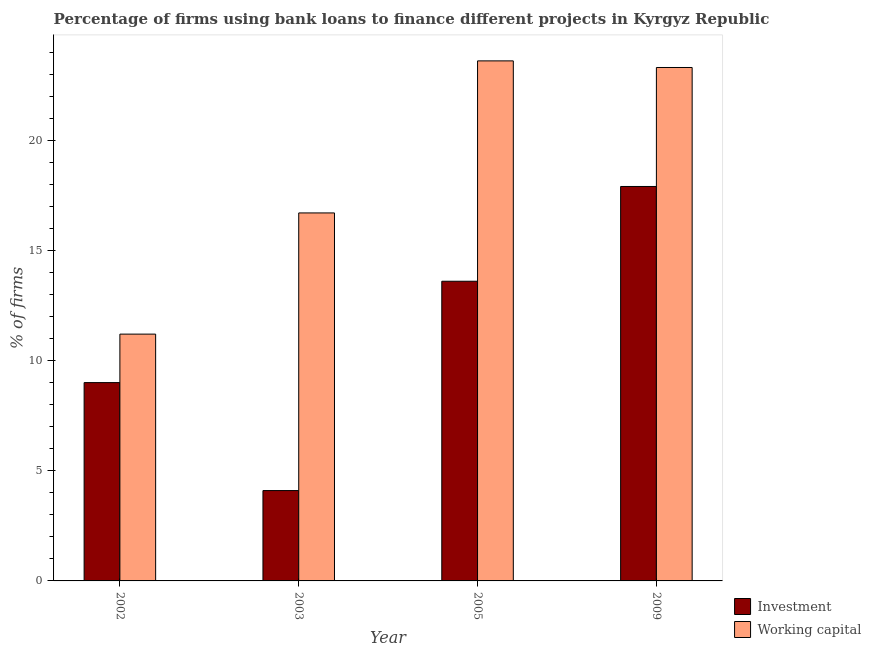How many different coloured bars are there?
Offer a terse response. 2. Are the number of bars on each tick of the X-axis equal?
Give a very brief answer. Yes. What is the label of the 3rd group of bars from the left?
Keep it short and to the point. 2005. What is the percentage of firms using banks to finance working capital in 2003?
Your response must be concise. 16.7. Across all years, what is the maximum percentage of firms using banks to finance investment?
Provide a succinct answer. 17.9. In which year was the percentage of firms using banks to finance investment minimum?
Offer a very short reply. 2003. What is the total percentage of firms using banks to finance investment in the graph?
Offer a very short reply. 44.6. What is the difference between the percentage of firms using banks to finance working capital in 2005 and that in 2009?
Your response must be concise. 0.3. What is the difference between the percentage of firms using banks to finance working capital in 2002 and the percentage of firms using banks to finance investment in 2003?
Ensure brevity in your answer.  -5.5. What is the average percentage of firms using banks to finance investment per year?
Your answer should be very brief. 11.15. In the year 2005, what is the difference between the percentage of firms using banks to finance working capital and percentage of firms using banks to finance investment?
Your response must be concise. 0. What is the ratio of the percentage of firms using banks to finance working capital in 2003 to that in 2009?
Offer a very short reply. 0.72. What is the difference between the highest and the second highest percentage of firms using banks to finance investment?
Provide a short and direct response. 4.3. What is the difference between the highest and the lowest percentage of firms using banks to finance investment?
Keep it short and to the point. 13.8. In how many years, is the percentage of firms using banks to finance investment greater than the average percentage of firms using banks to finance investment taken over all years?
Ensure brevity in your answer.  2. Is the sum of the percentage of firms using banks to finance working capital in 2002 and 2009 greater than the maximum percentage of firms using banks to finance investment across all years?
Provide a succinct answer. Yes. What does the 1st bar from the left in 2009 represents?
Provide a succinct answer. Investment. What does the 2nd bar from the right in 2002 represents?
Offer a terse response. Investment. How many years are there in the graph?
Offer a terse response. 4. Does the graph contain any zero values?
Provide a short and direct response. No. How many legend labels are there?
Provide a short and direct response. 2. What is the title of the graph?
Ensure brevity in your answer.  Percentage of firms using bank loans to finance different projects in Kyrgyz Republic. What is the label or title of the Y-axis?
Offer a terse response. % of firms. What is the % of firms of Investment in 2002?
Provide a short and direct response. 9. What is the % of firms in Working capital in 2002?
Your response must be concise. 11.2. What is the % of firms of Working capital in 2005?
Give a very brief answer. 23.6. What is the % of firms of Investment in 2009?
Offer a very short reply. 17.9. What is the % of firms in Working capital in 2009?
Offer a very short reply. 23.3. Across all years, what is the maximum % of firms of Working capital?
Your answer should be compact. 23.6. Across all years, what is the minimum % of firms in Working capital?
Ensure brevity in your answer.  11.2. What is the total % of firms of Investment in the graph?
Provide a short and direct response. 44.6. What is the total % of firms of Working capital in the graph?
Provide a succinct answer. 74.8. What is the difference between the % of firms of Investment in 2002 and that in 2005?
Your answer should be very brief. -4.6. What is the difference between the % of firms of Investment in 2002 and that in 2009?
Give a very brief answer. -8.9. What is the difference between the % of firms of Working capital in 2005 and that in 2009?
Make the answer very short. 0.3. What is the difference between the % of firms of Investment in 2002 and the % of firms of Working capital in 2003?
Provide a succinct answer. -7.7. What is the difference between the % of firms in Investment in 2002 and the % of firms in Working capital in 2005?
Your answer should be very brief. -14.6. What is the difference between the % of firms of Investment in 2002 and the % of firms of Working capital in 2009?
Your answer should be compact. -14.3. What is the difference between the % of firms in Investment in 2003 and the % of firms in Working capital in 2005?
Your answer should be very brief. -19.5. What is the difference between the % of firms of Investment in 2003 and the % of firms of Working capital in 2009?
Provide a succinct answer. -19.2. What is the average % of firms in Investment per year?
Your answer should be very brief. 11.15. In the year 2003, what is the difference between the % of firms of Investment and % of firms of Working capital?
Offer a very short reply. -12.6. In the year 2009, what is the difference between the % of firms in Investment and % of firms in Working capital?
Provide a succinct answer. -5.4. What is the ratio of the % of firms of Investment in 2002 to that in 2003?
Your answer should be very brief. 2.2. What is the ratio of the % of firms in Working capital in 2002 to that in 2003?
Keep it short and to the point. 0.67. What is the ratio of the % of firms of Investment in 2002 to that in 2005?
Offer a terse response. 0.66. What is the ratio of the % of firms of Working capital in 2002 to that in 2005?
Your answer should be compact. 0.47. What is the ratio of the % of firms in Investment in 2002 to that in 2009?
Offer a terse response. 0.5. What is the ratio of the % of firms in Working capital in 2002 to that in 2009?
Ensure brevity in your answer.  0.48. What is the ratio of the % of firms of Investment in 2003 to that in 2005?
Offer a very short reply. 0.3. What is the ratio of the % of firms in Working capital in 2003 to that in 2005?
Provide a succinct answer. 0.71. What is the ratio of the % of firms of Investment in 2003 to that in 2009?
Offer a terse response. 0.23. What is the ratio of the % of firms of Working capital in 2003 to that in 2009?
Make the answer very short. 0.72. What is the ratio of the % of firms of Investment in 2005 to that in 2009?
Your response must be concise. 0.76. What is the ratio of the % of firms of Working capital in 2005 to that in 2009?
Make the answer very short. 1.01. What is the difference between the highest and the second highest % of firms of Investment?
Your response must be concise. 4.3. What is the difference between the highest and the lowest % of firms of Investment?
Your response must be concise. 13.8. What is the difference between the highest and the lowest % of firms in Working capital?
Provide a short and direct response. 12.4. 